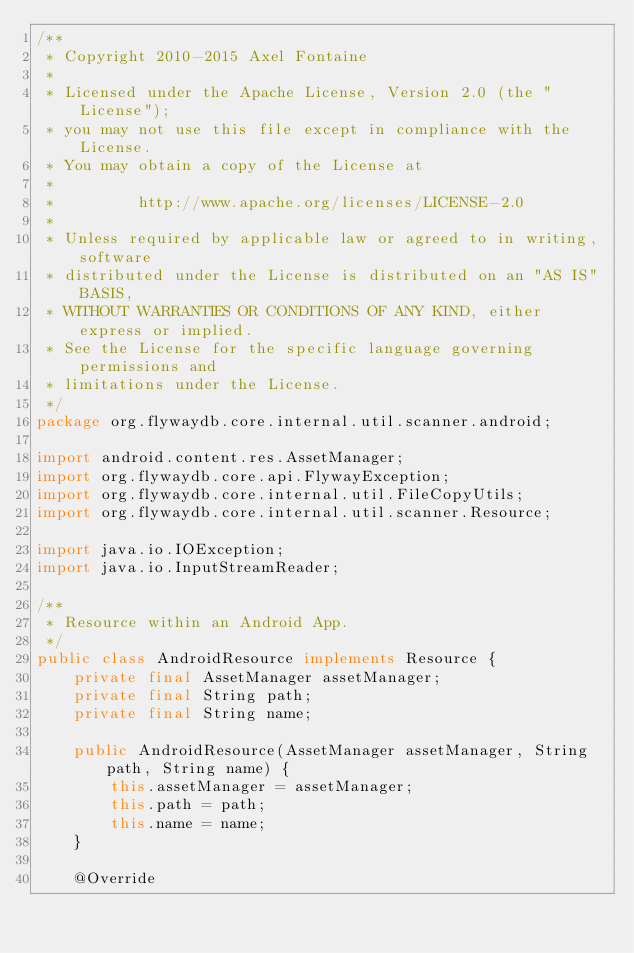Convert code to text. <code><loc_0><loc_0><loc_500><loc_500><_Java_>/**
 * Copyright 2010-2015 Axel Fontaine
 *
 * Licensed under the Apache License, Version 2.0 (the "License");
 * you may not use this file except in compliance with the License.
 * You may obtain a copy of the License at
 *
 *         http://www.apache.org/licenses/LICENSE-2.0
 *
 * Unless required by applicable law or agreed to in writing, software
 * distributed under the License is distributed on an "AS IS" BASIS,
 * WITHOUT WARRANTIES OR CONDITIONS OF ANY KIND, either express or implied.
 * See the License for the specific language governing permissions and
 * limitations under the License.
 */
package org.flywaydb.core.internal.util.scanner.android;

import android.content.res.AssetManager;
import org.flywaydb.core.api.FlywayException;
import org.flywaydb.core.internal.util.FileCopyUtils;
import org.flywaydb.core.internal.util.scanner.Resource;

import java.io.IOException;
import java.io.InputStreamReader;

/**
 * Resource within an Android App.
 */
public class AndroidResource implements Resource {
    private final AssetManager assetManager;
    private final String path;
    private final String name;

    public AndroidResource(AssetManager assetManager, String path, String name) {
        this.assetManager = assetManager;
        this.path = path;
        this.name = name;
    }

    @Override</code> 